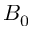Convert formula to latex. <formula><loc_0><loc_0><loc_500><loc_500>B _ { 0 }</formula> 